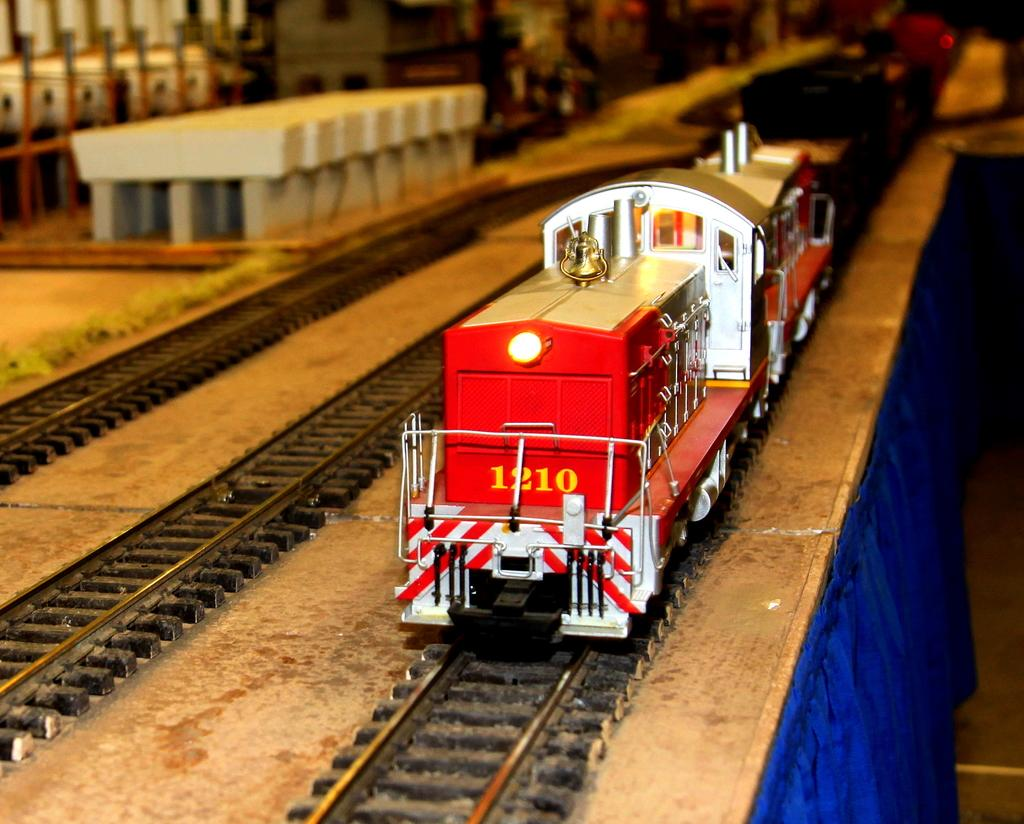What is the main subject of the image? The main subject of the image is a train. Can you describe the color of the train? The train is in white and red color. Where is the train located in the image? The train is on a track. What can be seen in the background of the image? There is a building in the background of the image. Can you describe the color of the building? The building is white in color. What other object or item can be seen in the image? There is a blue cloth visible in the image. What type of rhythm does the chalk create while drawing on the train in the image? There is no chalk or drawing activity present in the image; it features a train on a track with a white and red color scheme and a white building in the background. 